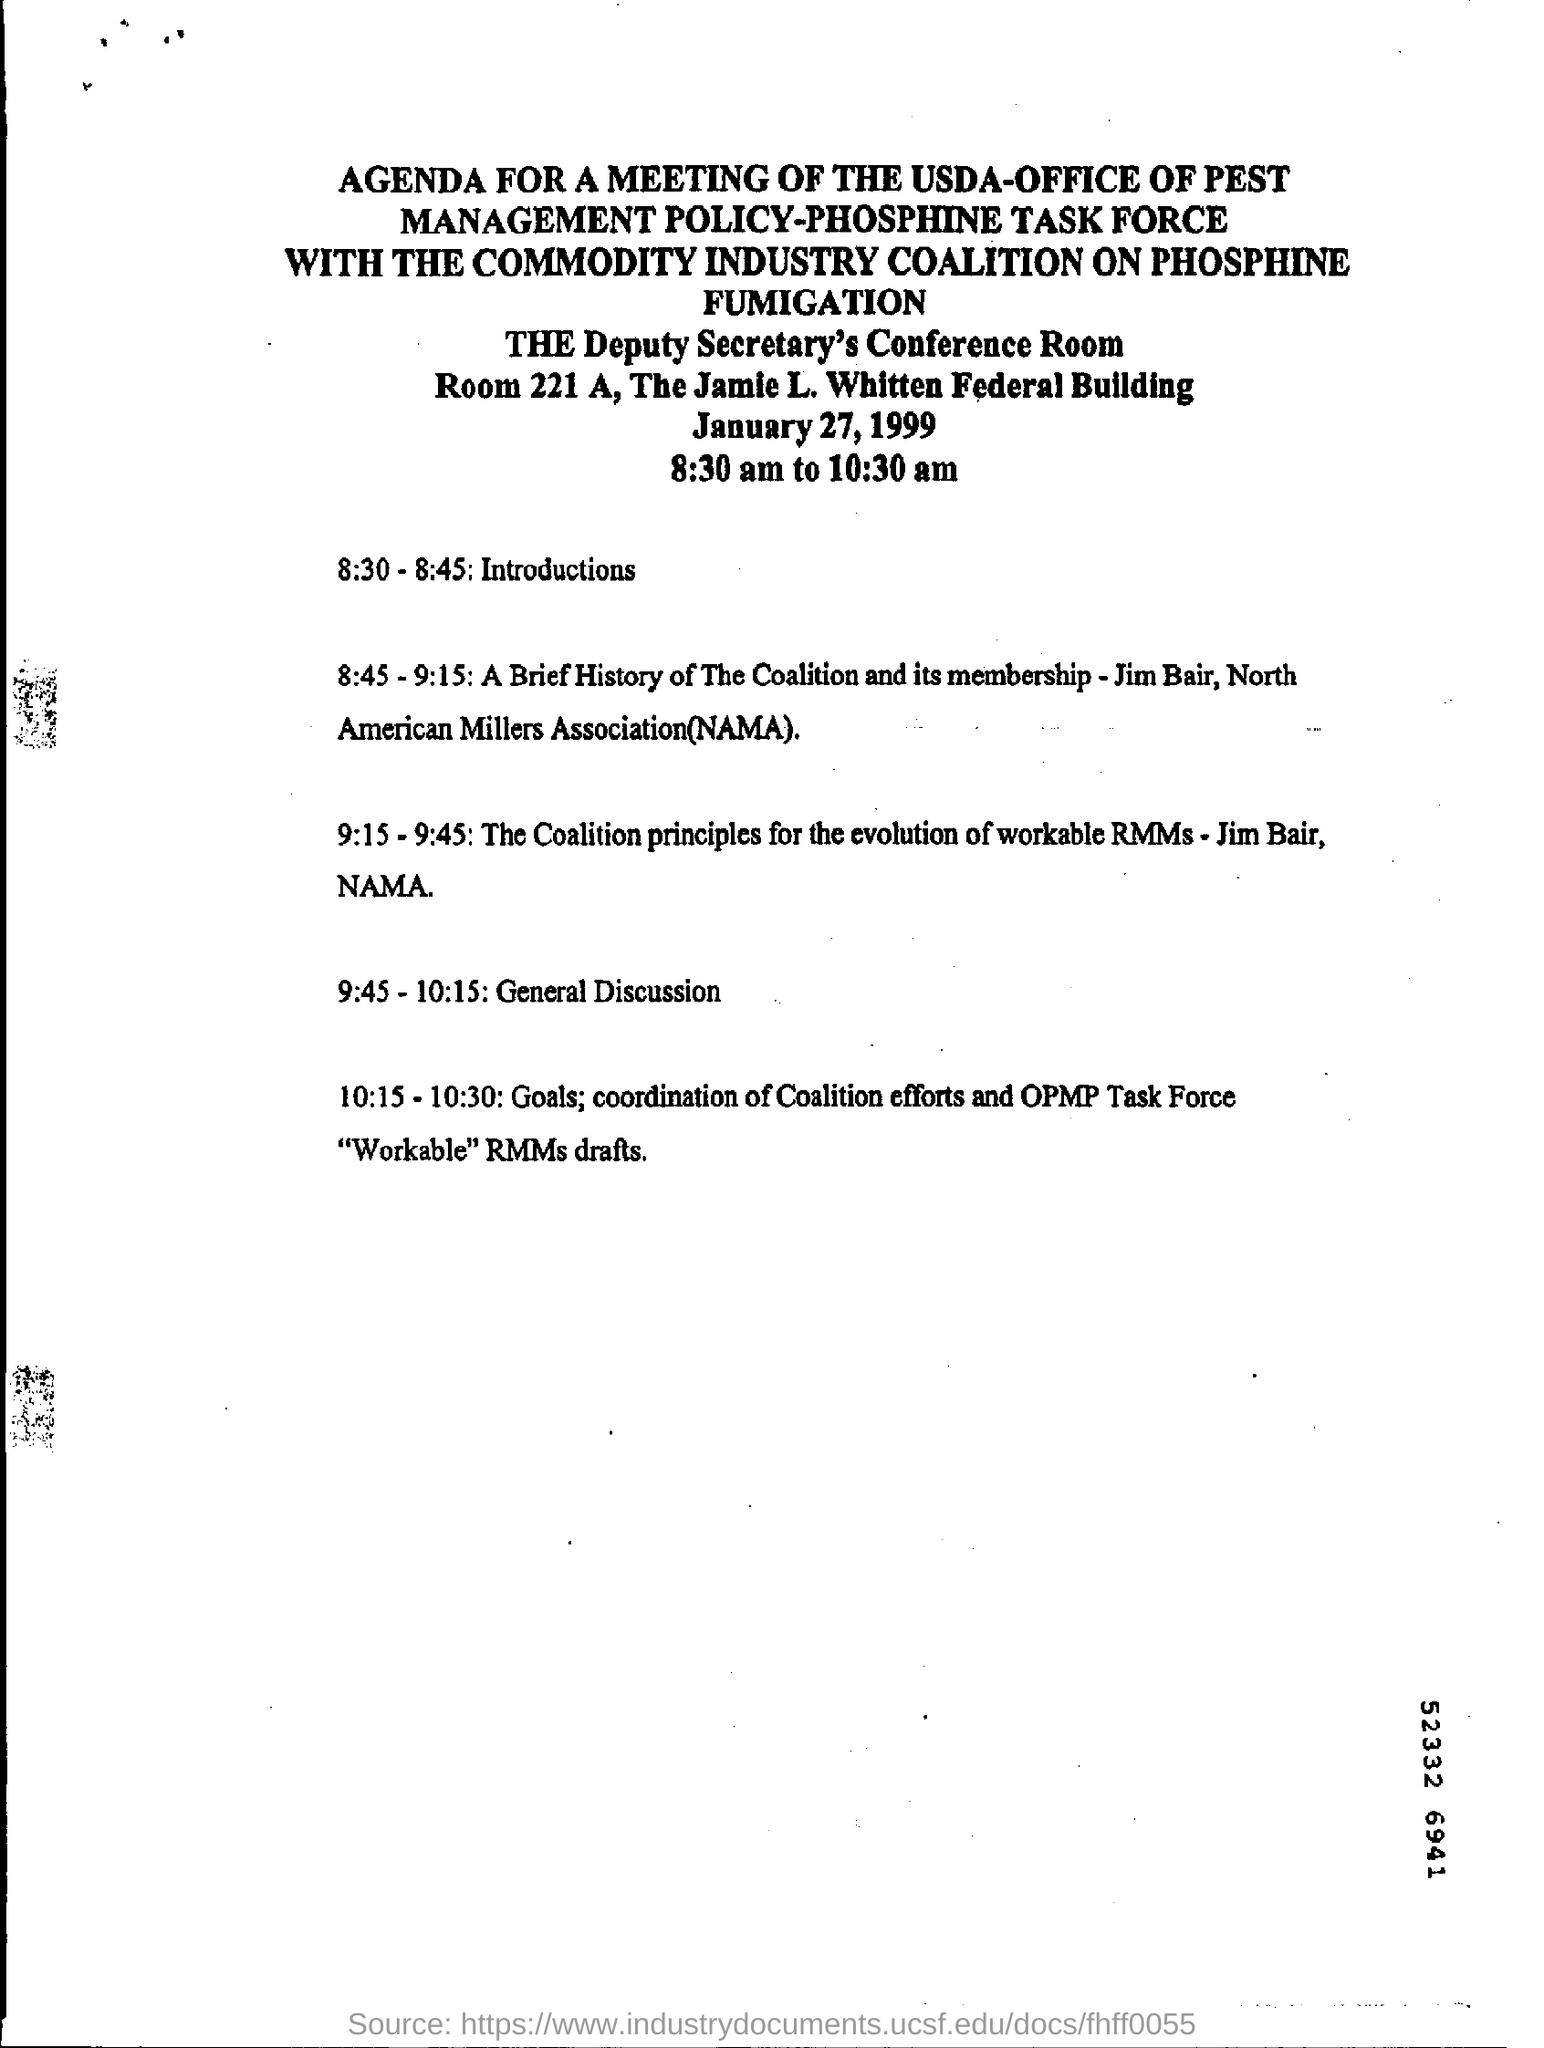Highlight a few significant elements in this photo. The meeting was conducted in Room 221, as per the agenda that was printed. The date of the meeting, as specified in the agenda notice, is January 27, 1999. The functioning room is Room 221 A, which is the Deputy Secretary's Conference Room. According to the agenda, introductions are scheduled to take place between 8:30 and 8:45. The meeting is scheduled to take place between 8:30 am and 10:30 am. 